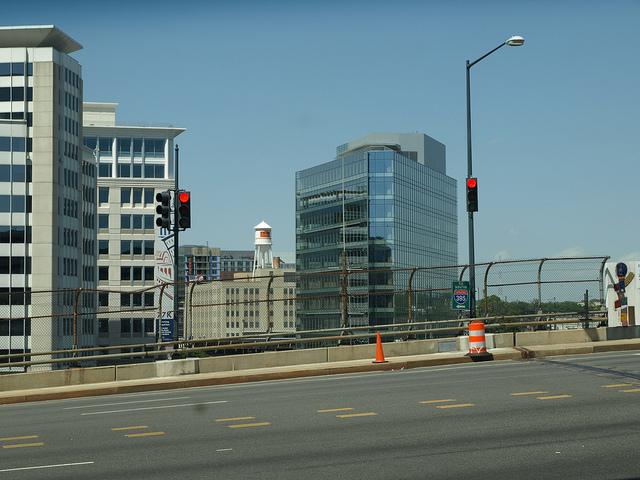Would one assume that a road crew has visited this locality recently?
Concise answer only. Yes. Is there a bus in the street?
Answer briefly. No. What time of day is it?
Short answer required. Afternoon. Is there a water tower?
Quick response, please. Yes. How many orange cones are visible?
Give a very brief answer. 2. Is the picture blurry?
Write a very short answer. No. How many cones are there?
Quick response, please. 1. Are there any cars in the street?
Short answer required. No. Is there are scooter?
Keep it brief. No. Where is the traffic sign?
Answer briefly. Pole. When were these stoplights installed in the picture?
Give a very brief answer. Recently. Do the horizontal stripes dominate this space?
Quick response, please. No. What color is the signal light?
Give a very brief answer. Red. Is it night time?
Write a very short answer. No. What color is the fence?
Write a very short answer. Brown. Are there blurry people on the street?
Quick response, please. No. Have these buildings been recently updated?
Answer briefly. Yes. How many cars are there?
Give a very brief answer. 0. 